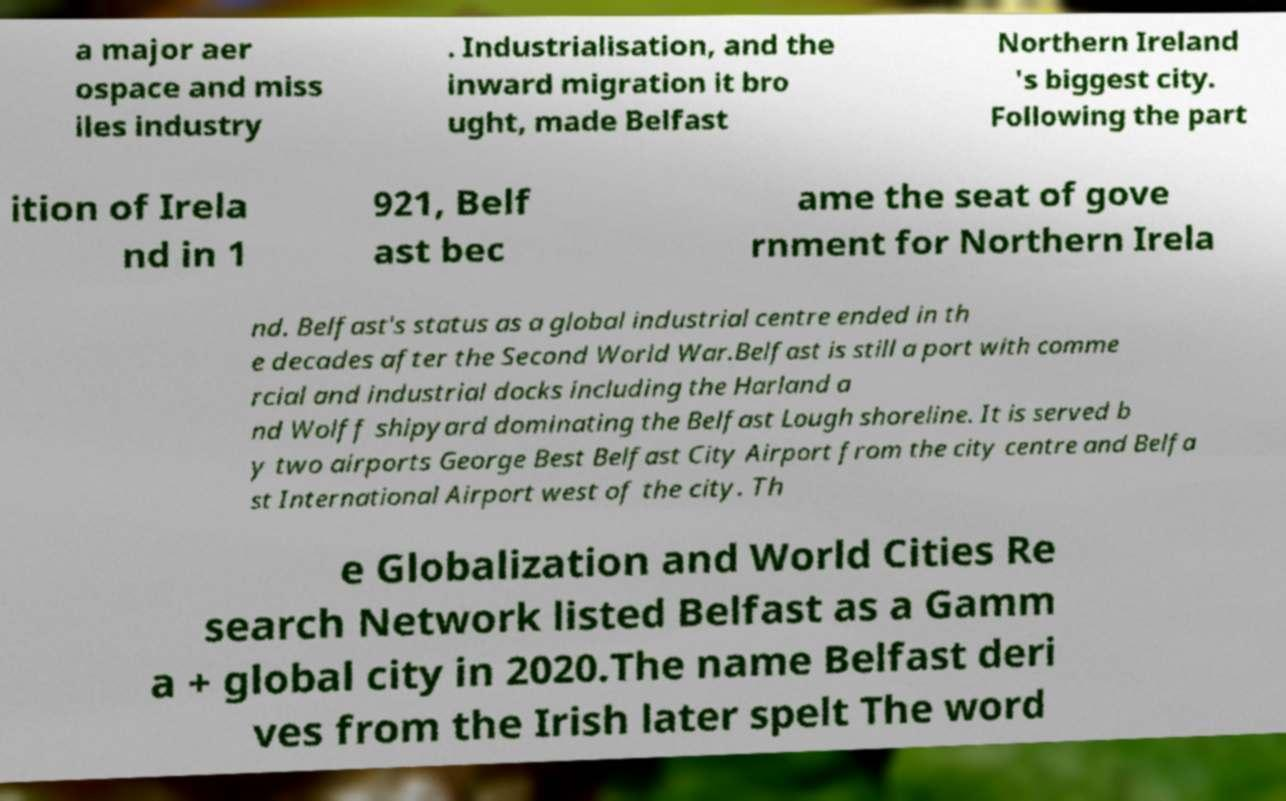I need the written content from this picture converted into text. Can you do that? a major aer ospace and miss iles industry . Industrialisation, and the inward migration it bro ught, made Belfast Northern Ireland 's biggest city. Following the part ition of Irela nd in 1 921, Belf ast bec ame the seat of gove rnment for Northern Irela nd. Belfast's status as a global industrial centre ended in th e decades after the Second World War.Belfast is still a port with comme rcial and industrial docks including the Harland a nd Wolff shipyard dominating the Belfast Lough shoreline. It is served b y two airports George Best Belfast City Airport from the city centre and Belfa st International Airport west of the city. Th e Globalization and World Cities Re search Network listed Belfast as a Gamm a + global city in 2020.The name Belfast deri ves from the Irish later spelt The word 